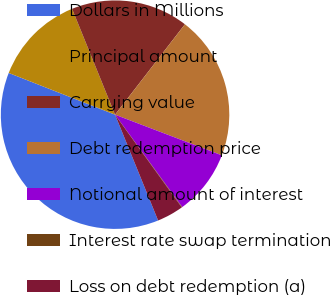Convert chart to OTSL. <chart><loc_0><loc_0><loc_500><loc_500><pie_chart><fcel>Dollars in Millions<fcel>Principal amount<fcel>Carrying value<fcel>Debt redemption price<fcel>Notional amount of interest<fcel>Interest rate swap termination<fcel>Loss on debt redemption (a)<nl><fcel>37.1%<fcel>12.91%<fcel>16.61%<fcel>20.32%<fcel>9.21%<fcel>0.07%<fcel>3.78%<nl></chart> 